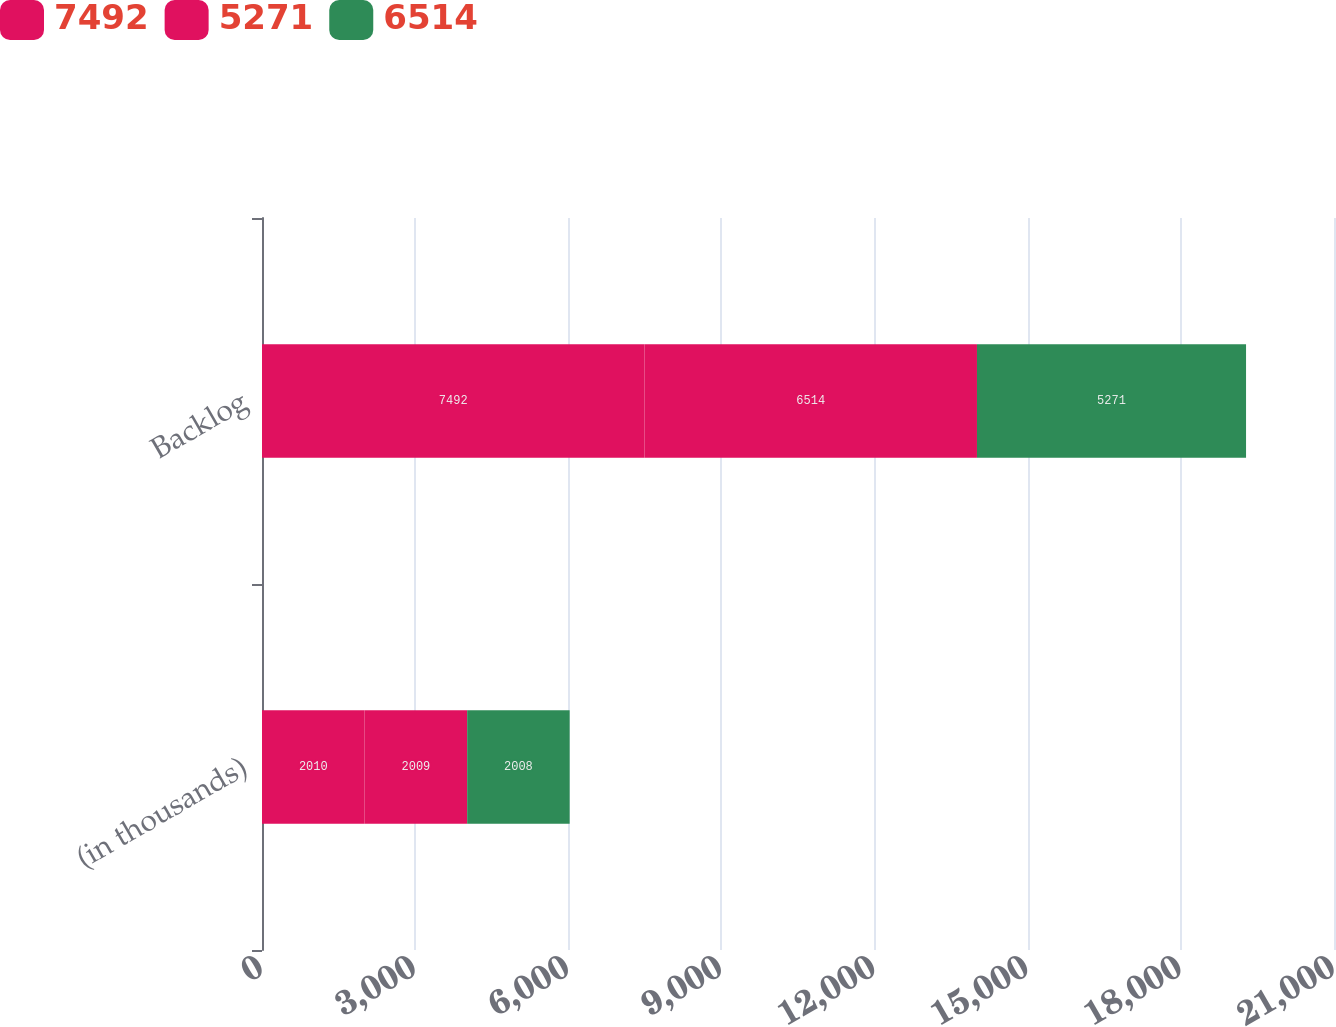Convert chart. <chart><loc_0><loc_0><loc_500><loc_500><stacked_bar_chart><ecel><fcel>(in thousands)<fcel>Backlog<nl><fcel>7492<fcel>2010<fcel>7492<nl><fcel>5271<fcel>2009<fcel>6514<nl><fcel>6514<fcel>2008<fcel>5271<nl></chart> 